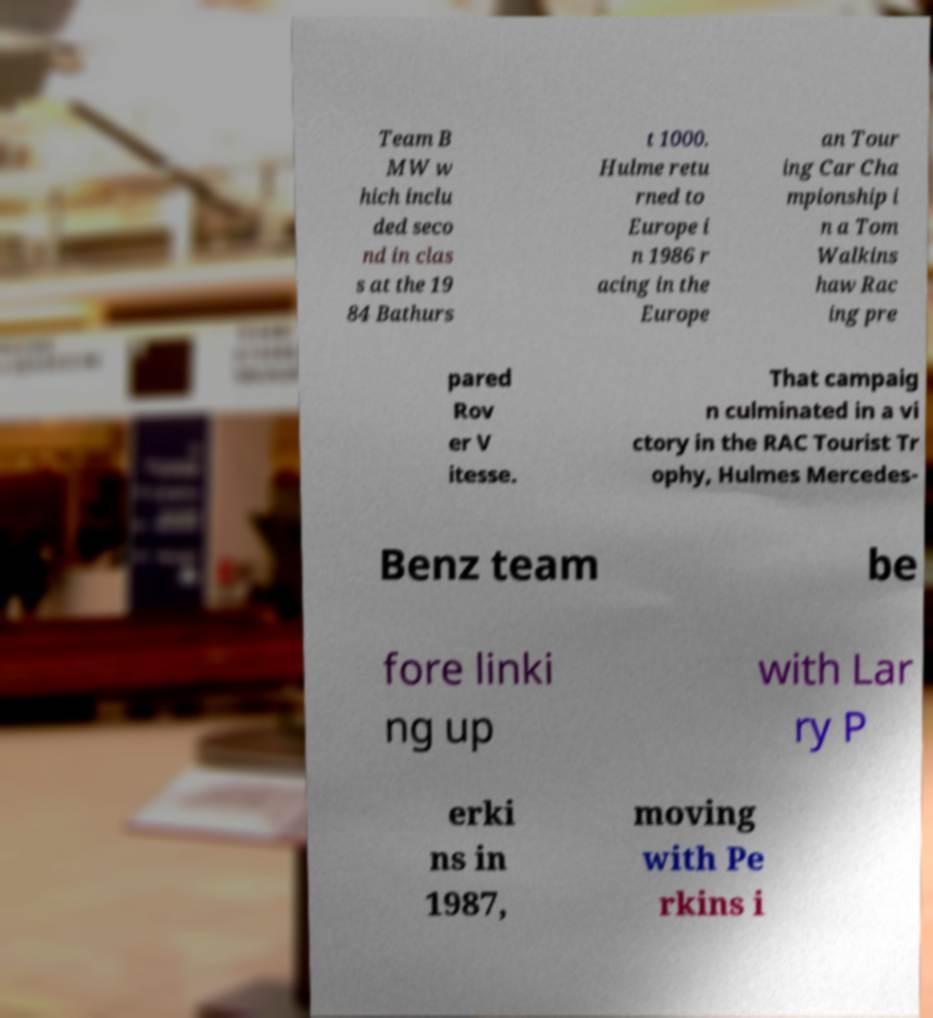Can you read and provide the text displayed in the image?This photo seems to have some interesting text. Can you extract and type it out for me? Team B MW w hich inclu ded seco nd in clas s at the 19 84 Bathurs t 1000. Hulme retu rned to Europe i n 1986 r acing in the Europe an Tour ing Car Cha mpionship i n a Tom Walkins haw Rac ing pre pared Rov er V itesse. That campaig n culminated in a vi ctory in the RAC Tourist Tr ophy, Hulmes Mercedes- Benz team be fore linki ng up with Lar ry P erki ns in 1987, moving with Pe rkins i 